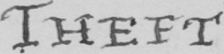Can you tell me what this handwritten text says? THEFT 